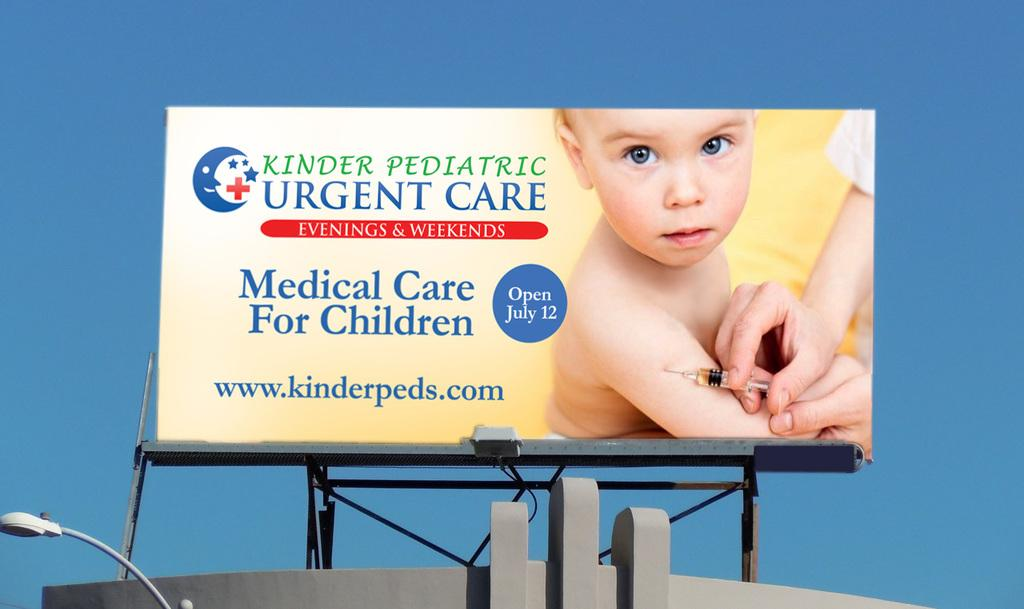<image>
Provide a brief description of the given image. a billboard that says 'kinder pediatric urgent care' 